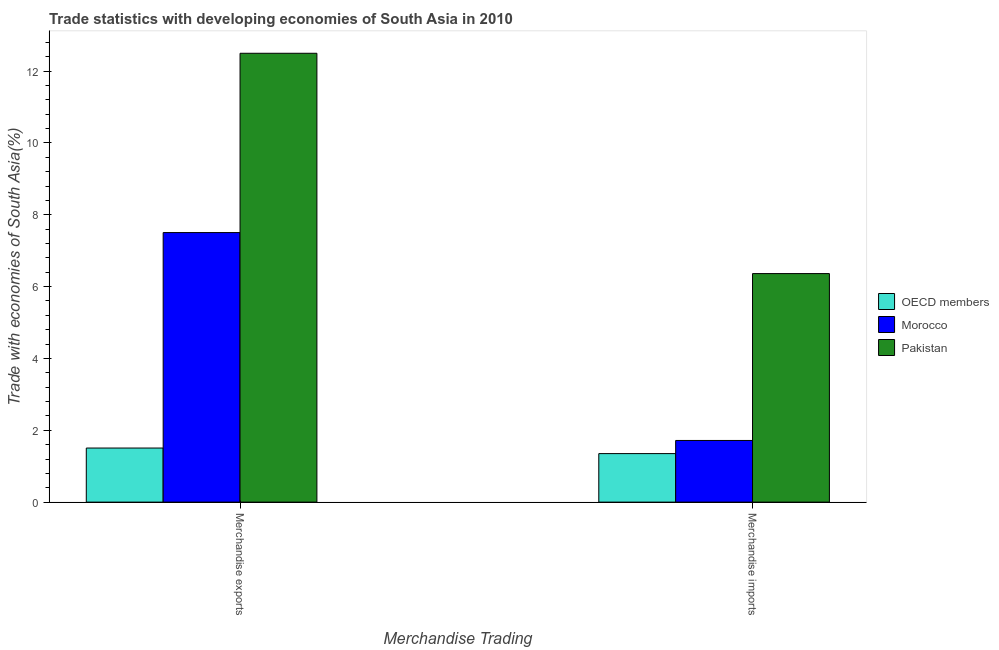How many different coloured bars are there?
Ensure brevity in your answer.  3. How many groups of bars are there?
Provide a succinct answer. 2. Are the number of bars per tick equal to the number of legend labels?
Ensure brevity in your answer.  Yes. How many bars are there on the 2nd tick from the left?
Give a very brief answer. 3. How many bars are there on the 2nd tick from the right?
Your response must be concise. 3. What is the merchandise imports in Morocco?
Give a very brief answer. 1.72. Across all countries, what is the maximum merchandise imports?
Make the answer very short. 6.36. Across all countries, what is the minimum merchandise imports?
Offer a very short reply. 1.35. In which country was the merchandise imports maximum?
Your response must be concise. Pakistan. What is the total merchandise imports in the graph?
Your answer should be compact. 9.43. What is the difference between the merchandise exports in Morocco and that in OECD members?
Offer a very short reply. 6. What is the difference between the merchandise imports in Pakistan and the merchandise exports in OECD members?
Keep it short and to the point. 4.86. What is the average merchandise exports per country?
Give a very brief answer. 7.17. What is the difference between the merchandise imports and merchandise exports in OECD members?
Give a very brief answer. -0.15. In how many countries, is the merchandise imports greater than 10.8 %?
Provide a short and direct response. 0. What is the ratio of the merchandise imports in OECD members to that in Morocco?
Your response must be concise. 0.79. What does the 2nd bar from the left in Merchandise exports represents?
Your answer should be compact. Morocco. What is the difference between two consecutive major ticks on the Y-axis?
Your answer should be very brief. 2. Are the values on the major ticks of Y-axis written in scientific E-notation?
Your response must be concise. No. How many legend labels are there?
Your answer should be very brief. 3. What is the title of the graph?
Make the answer very short. Trade statistics with developing economies of South Asia in 2010. Does "Canada" appear as one of the legend labels in the graph?
Give a very brief answer. No. What is the label or title of the X-axis?
Ensure brevity in your answer.  Merchandise Trading. What is the label or title of the Y-axis?
Give a very brief answer. Trade with economies of South Asia(%). What is the Trade with economies of South Asia(%) of OECD members in Merchandise exports?
Provide a short and direct response. 1.51. What is the Trade with economies of South Asia(%) in Morocco in Merchandise exports?
Your answer should be very brief. 7.5. What is the Trade with economies of South Asia(%) in Pakistan in Merchandise exports?
Your answer should be compact. 12.5. What is the Trade with economies of South Asia(%) of OECD members in Merchandise imports?
Give a very brief answer. 1.35. What is the Trade with economies of South Asia(%) in Morocco in Merchandise imports?
Offer a very short reply. 1.72. What is the Trade with economies of South Asia(%) of Pakistan in Merchandise imports?
Provide a succinct answer. 6.36. Across all Merchandise Trading, what is the maximum Trade with economies of South Asia(%) in OECD members?
Your answer should be very brief. 1.51. Across all Merchandise Trading, what is the maximum Trade with economies of South Asia(%) of Morocco?
Your answer should be compact. 7.5. Across all Merchandise Trading, what is the maximum Trade with economies of South Asia(%) in Pakistan?
Offer a terse response. 12.5. Across all Merchandise Trading, what is the minimum Trade with economies of South Asia(%) of OECD members?
Offer a terse response. 1.35. Across all Merchandise Trading, what is the minimum Trade with economies of South Asia(%) in Morocco?
Provide a succinct answer. 1.72. Across all Merchandise Trading, what is the minimum Trade with economies of South Asia(%) of Pakistan?
Give a very brief answer. 6.36. What is the total Trade with economies of South Asia(%) in OECD members in the graph?
Offer a very short reply. 2.86. What is the total Trade with economies of South Asia(%) in Morocco in the graph?
Ensure brevity in your answer.  9.22. What is the total Trade with economies of South Asia(%) of Pakistan in the graph?
Make the answer very short. 18.86. What is the difference between the Trade with economies of South Asia(%) of OECD members in Merchandise exports and that in Merchandise imports?
Your response must be concise. 0.15. What is the difference between the Trade with economies of South Asia(%) of Morocco in Merchandise exports and that in Merchandise imports?
Give a very brief answer. 5.79. What is the difference between the Trade with economies of South Asia(%) of Pakistan in Merchandise exports and that in Merchandise imports?
Offer a very short reply. 6.13. What is the difference between the Trade with economies of South Asia(%) in OECD members in Merchandise exports and the Trade with economies of South Asia(%) in Morocco in Merchandise imports?
Make the answer very short. -0.21. What is the difference between the Trade with economies of South Asia(%) of OECD members in Merchandise exports and the Trade with economies of South Asia(%) of Pakistan in Merchandise imports?
Ensure brevity in your answer.  -4.86. What is the difference between the Trade with economies of South Asia(%) in Morocco in Merchandise exports and the Trade with economies of South Asia(%) in Pakistan in Merchandise imports?
Your response must be concise. 1.14. What is the average Trade with economies of South Asia(%) in OECD members per Merchandise Trading?
Your response must be concise. 1.43. What is the average Trade with economies of South Asia(%) of Morocco per Merchandise Trading?
Your response must be concise. 4.61. What is the average Trade with economies of South Asia(%) in Pakistan per Merchandise Trading?
Provide a short and direct response. 9.43. What is the difference between the Trade with economies of South Asia(%) of OECD members and Trade with economies of South Asia(%) of Morocco in Merchandise exports?
Give a very brief answer. -6. What is the difference between the Trade with economies of South Asia(%) of OECD members and Trade with economies of South Asia(%) of Pakistan in Merchandise exports?
Offer a very short reply. -10.99. What is the difference between the Trade with economies of South Asia(%) of Morocco and Trade with economies of South Asia(%) of Pakistan in Merchandise exports?
Make the answer very short. -4.99. What is the difference between the Trade with economies of South Asia(%) in OECD members and Trade with economies of South Asia(%) in Morocco in Merchandise imports?
Offer a terse response. -0.37. What is the difference between the Trade with economies of South Asia(%) of OECD members and Trade with economies of South Asia(%) of Pakistan in Merchandise imports?
Offer a terse response. -5.01. What is the difference between the Trade with economies of South Asia(%) in Morocco and Trade with economies of South Asia(%) in Pakistan in Merchandise imports?
Keep it short and to the point. -4.65. What is the ratio of the Trade with economies of South Asia(%) in OECD members in Merchandise exports to that in Merchandise imports?
Make the answer very short. 1.11. What is the ratio of the Trade with economies of South Asia(%) in Morocco in Merchandise exports to that in Merchandise imports?
Offer a very short reply. 4.37. What is the ratio of the Trade with economies of South Asia(%) in Pakistan in Merchandise exports to that in Merchandise imports?
Keep it short and to the point. 1.96. What is the difference between the highest and the second highest Trade with economies of South Asia(%) in OECD members?
Keep it short and to the point. 0.15. What is the difference between the highest and the second highest Trade with economies of South Asia(%) of Morocco?
Provide a succinct answer. 5.79. What is the difference between the highest and the second highest Trade with economies of South Asia(%) of Pakistan?
Your answer should be very brief. 6.13. What is the difference between the highest and the lowest Trade with economies of South Asia(%) of OECD members?
Provide a succinct answer. 0.15. What is the difference between the highest and the lowest Trade with economies of South Asia(%) of Morocco?
Offer a very short reply. 5.79. What is the difference between the highest and the lowest Trade with economies of South Asia(%) of Pakistan?
Offer a terse response. 6.13. 